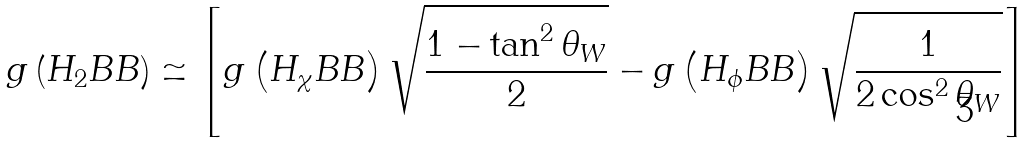Convert formula to latex. <formula><loc_0><loc_0><loc_500><loc_500>g \left ( H _ { 2 } B B \right ) \simeq \left [ g \left ( H _ { \chi } B B \right ) \sqrt { \frac { 1 - \tan ^ { 2 } \theta _ { W } } { 2 } } - g \left ( H _ { \phi } B B \right ) \sqrt { \frac { 1 } { 2 \cos ^ { 2 } \theta _ { W } } } \right ]</formula> 